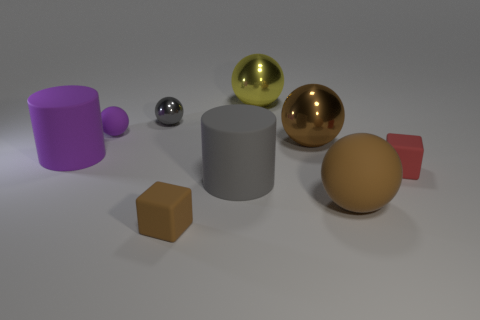What objects in the image could be from the same set? The gold and silver spheres could belong to the same set, given their similar reflective surfaces and spherical shape. 